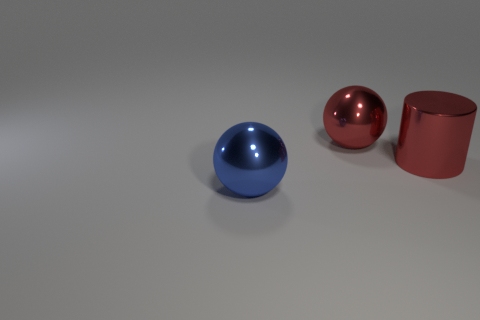Are there any big blue shiny objects in front of the cylinder?
Provide a short and direct response. Yes. There is a red object that is the same shape as the blue metal object; what material is it?
Offer a very short reply. Metal. How many other objects are there of the same shape as the blue shiny thing?
Ensure brevity in your answer.  1. There is a large blue ball on the left side of the large ball right of the big blue metallic ball; what number of large metallic balls are behind it?
Make the answer very short. 1. What number of tiny cyan things are the same shape as the large blue shiny object?
Give a very brief answer. 0. There is a metal sphere behind the big blue shiny thing; is its color the same as the cylinder?
Provide a succinct answer. Yes. There is a metal thing on the left side of the red object behind the large red thing in front of the big red shiny ball; what shape is it?
Your answer should be very brief. Sphere. Are there any other red cylinders of the same size as the red cylinder?
Your answer should be compact. No. How many other objects are the same material as the big red cylinder?
Offer a terse response. 2. The object that is both to the left of the red cylinder and in front of the large red metal ball is what color?
Your answer should be compact. Blue. 